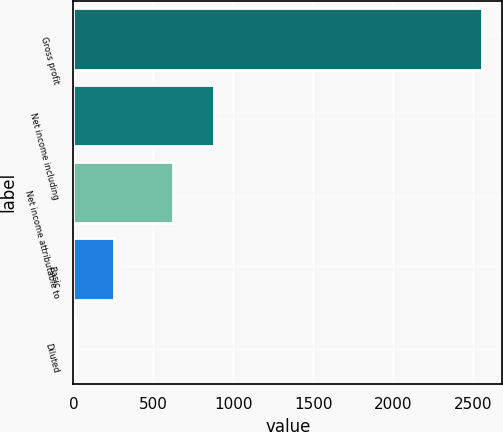Convert chart to OTSL. <chart><loc_0><loc_0><loc_500><loc_500><bar_chart><fcel>Gross profit<fcel>Net income including<fcel>Net income attributable to<fcel>Basic<fcel>Diluted<nl><fcel>2552<fcel>877.13<fcel>622<fcel>255.8<fcel>0.67<nl></chart> 